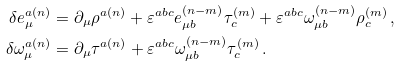Convert formula to latex. <formula><loc_0><loc_0><loc_500><loc_500>\delta e _ { \mu } ^ { a ( n ) } & = \partial _ { \mu } \rho ^ { a ( n ) } + \varepsilon ^ { a b c } e _ { \mu b } ^ { ( n - m ) } \tau _ { c } ^ { ( m ) } + \varepsilon ^ { a b c } \omega _ { \mu b } ^ { ( n - m ) } \rho _ { c } ^ { ( m ) } \, , \\ \delta \omega _ { \mu } ^ { a ( n ) } & = \partial _ { \mu } \tau ^ { a ( n ) } + \varepsilon ^ { a b c } \omega _ { \mu b } ^ { ( n - m ) } \tau _ { c } ^ { ( m ) } \, .</formula> 